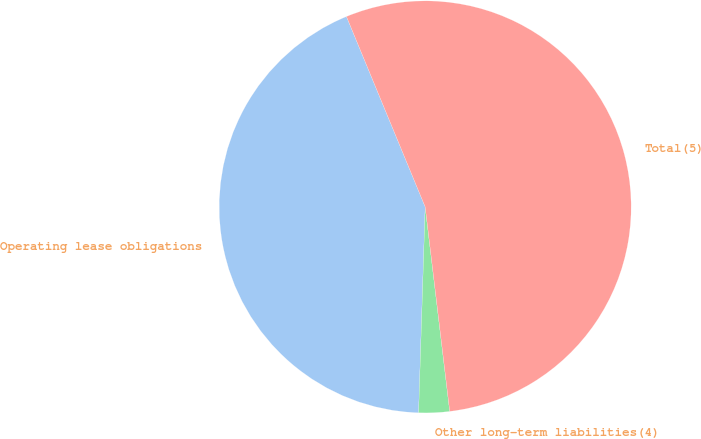Convert chart to OTSL. <chart><loc_0><loc_0><loc_500><loc_500><pie_chart><fcel>Operating lease obligations<fcel>Other long-term liabilities(4)<fcel>Total(5)<nl><fcel>43.25%<fcel>2.41%<fcel>54.34%<nl></chart> 